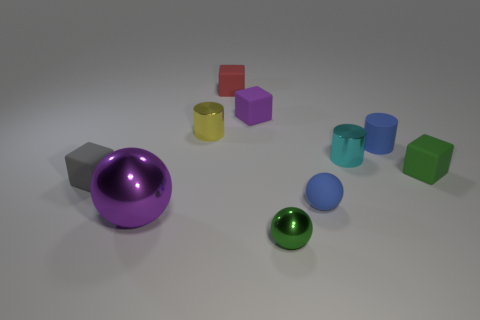What size is the object that is the same color as the tiny matte cylinder?
Ensure brevity in your answer.  Small. There is a small thing that is the same color as the matte cylinder; what is its shape?
Offer a terse response. Sphere. What number of other objects are there of the same material as the yellow cylinder?
Ensure brevity in your answer.  3. What number of rubber objects are both left of the big purple shiny sphere and in front of the gray matte cube?
Offer a terse response. 0. The green object behind the small rubber block that is left of the tiny red matte object is made of what material?
Make the answer very short. Rubber. What is the material of the small green thing that is the same shape as the gray thing?
Keep it short and to the point. Rubber. Are any tiny red metallic things visible?
Keep it short and to the point. No. There is a green thing that is the same material as the small gray cube; what is its shape?
Your answer should be compact. Cube. What is the purple thing on the right side of the tiny yellow cylinder made of?
Offer a terse response. Rubber. There is a tiny object that is to the right of the blue cylinder; does it have the same color as the tiny metallic sphere?
Offer a terse response. Yes. 